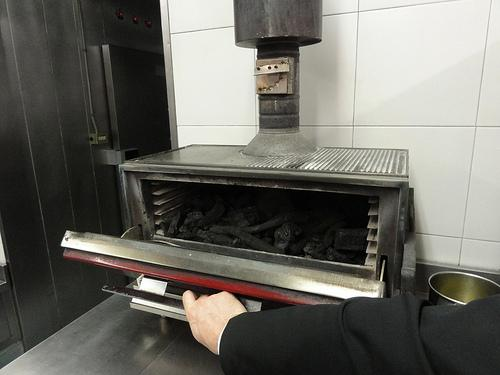Estimate the number of objects made of metal in this image. Approximately 10 metal objects are present, like grey metal, metal pipe, heater pipe, red and silver handles, stainless steel bowl, steel counter, racks, and heater top. Is the man in the image wearing formal or casual clothing? The man in the image is wearing formal clothing, indicated by his black suit sleeve. What is the primary function of the oven cooker in this image? The primary function of the oven cooker is to heat and cook food, using wood and charcoal for fuel. Briefly describe the scene shown in the image. A man in a black suit is interacting with a small oven cooker, possibly adding wood or charcoal for heating, surrounded by various heating-related objects and kitchen equipment. List all the objects you can detect in this image. Hand on handle, wood sticks in stove, black panels, grey metal, metal pipe, white board, silver bowl, black sleeve, red handle, white shirt, charcoal heater, man's right hand, charcoal, bowl, white tile, heater handle, heater pipe, racks, heater top, steel counter, oven stove pipe, oven cooker, stainless steel bowl, silver handle, man's right arm, white tiles, inside of oven, charcoal and wood in oven, man in black suit, small oven. Among the objects detected in the image, how many are related to the heating process? At least 12 objects are related to the heating process, such as wood, charcoal, oven cooker, heater pipe, stove pipe, metal pipe, red handle on stove, handle of heater door, silver handle on cooker, inside of oven, charcoal and wood in oven, small oven. Can you describe the quality of the image, like if it's high quality, grainy, or blurry? The image quality appears to be high, with clear and detailed representation of objects and their positions within the scene. In the context of the image, what interaction is taking place between the man and the oven cooker? The man is tending to the oven cooker, using his right hand to hold the handle and possibly add wood or charcoal to the heater. What can you infer about the purpose or intention of the man in the image?  The man seems to be monitoring or tending to the oven cooker, perhaps to ensure proper heat and cooking functionality, possibly in a professional or formal setting. How would you describe the overall ambiance of the image? The image has a busy and functional ambiance, with several objects related to the heating and cooking process in a kitchen setting. 